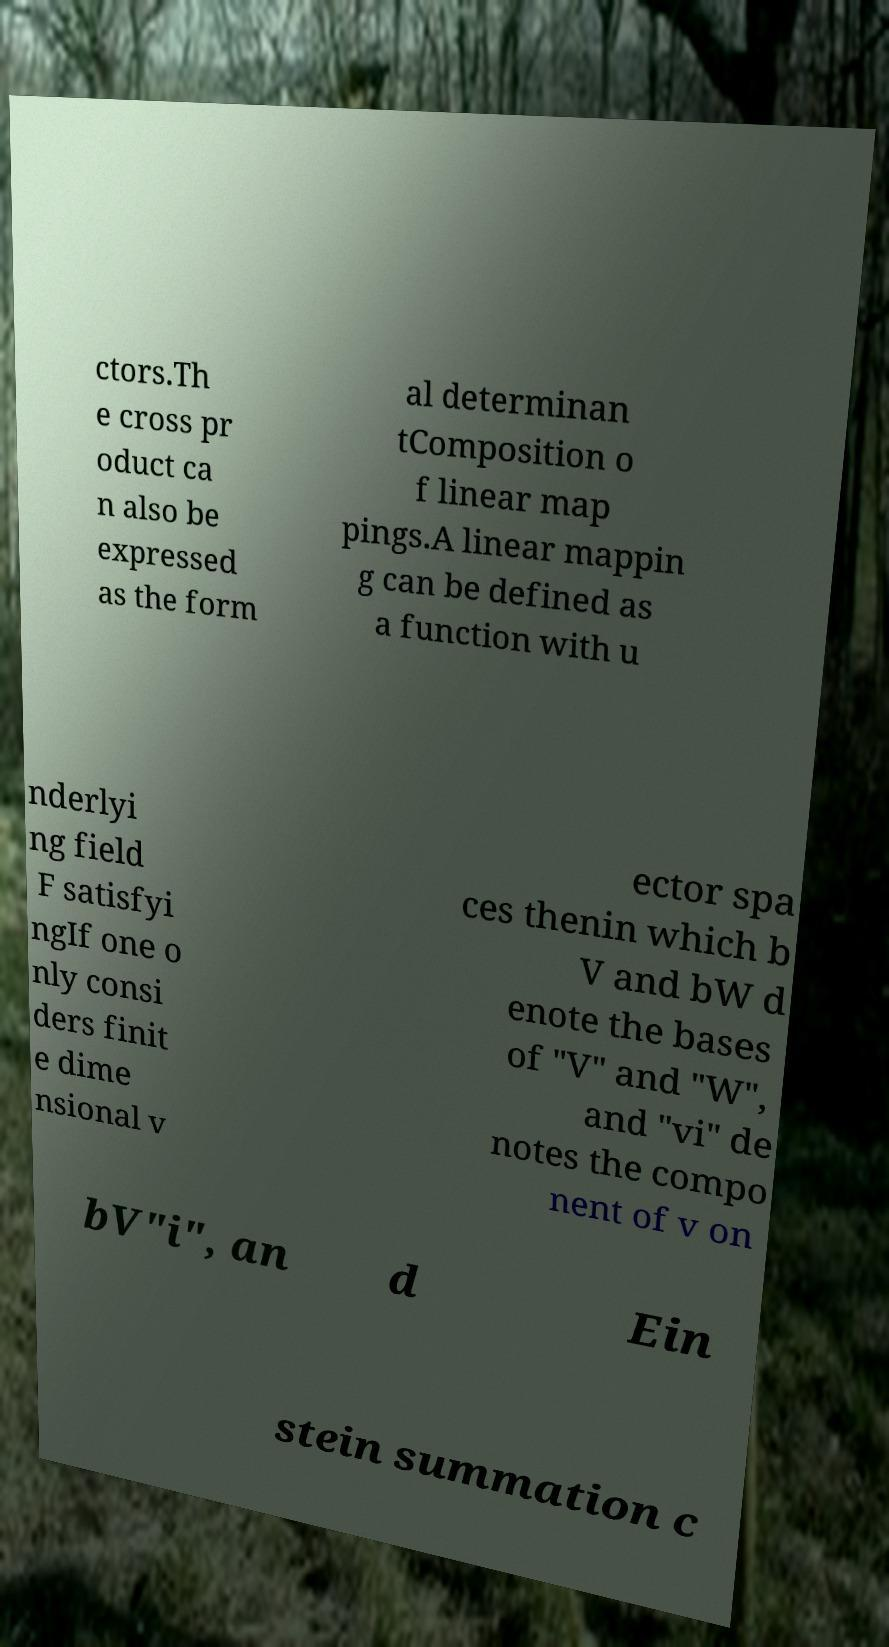There's text embedded in this image that I need extracted. Can you transcribe it verbatim? ctors.Th e cross pr oduct ca n also be expressed as the form al determinan tComposition o f linear map pings.A linear mappin g can be defined as a function with u nderlyi ng field F satisfyi ngIf one o nly consi ders finit e dime nsional v ector spa ces thenin which b V and bW d enote the bases of "V" and "W", and "vi" de notes the compo nent of v on bV"i", an d Ein stein summation c 